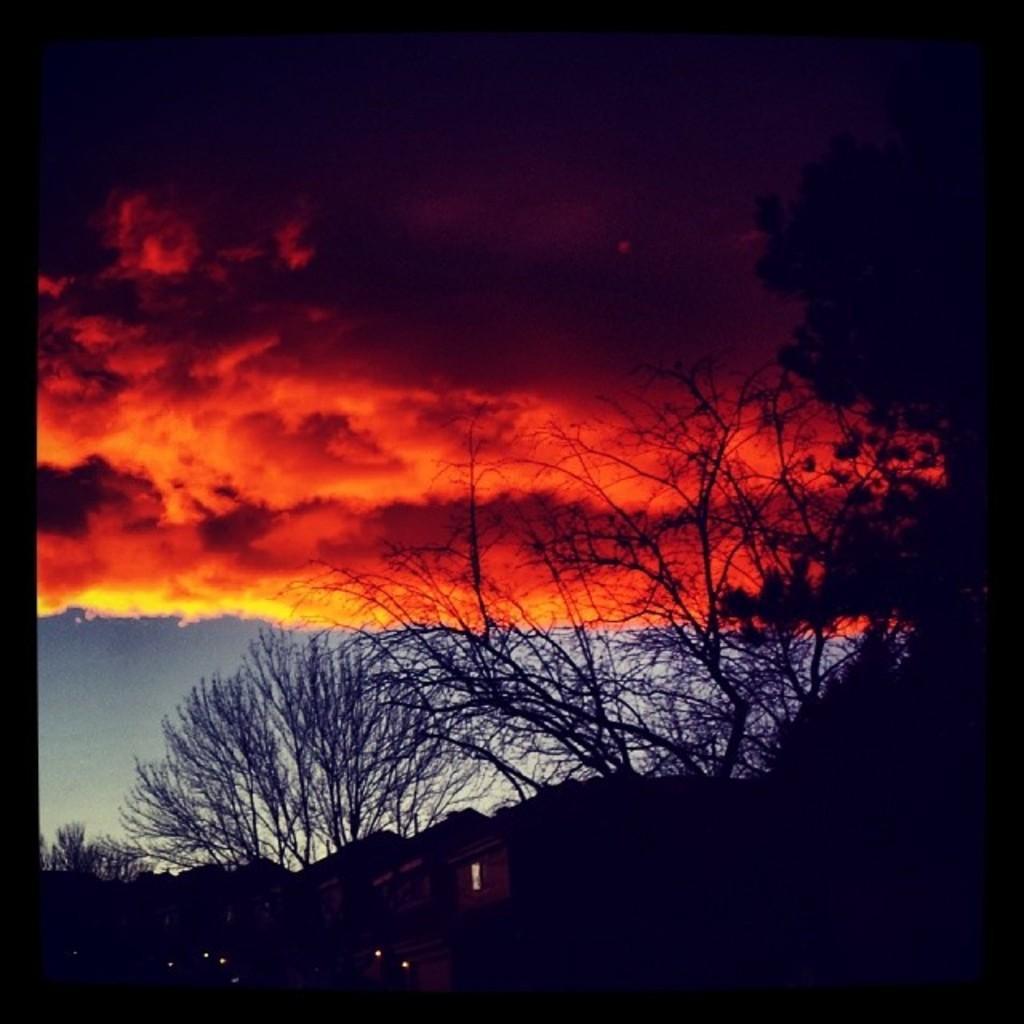Describe this image in one or two sentences. In this image we can see trees, houses, sky and clouds. 